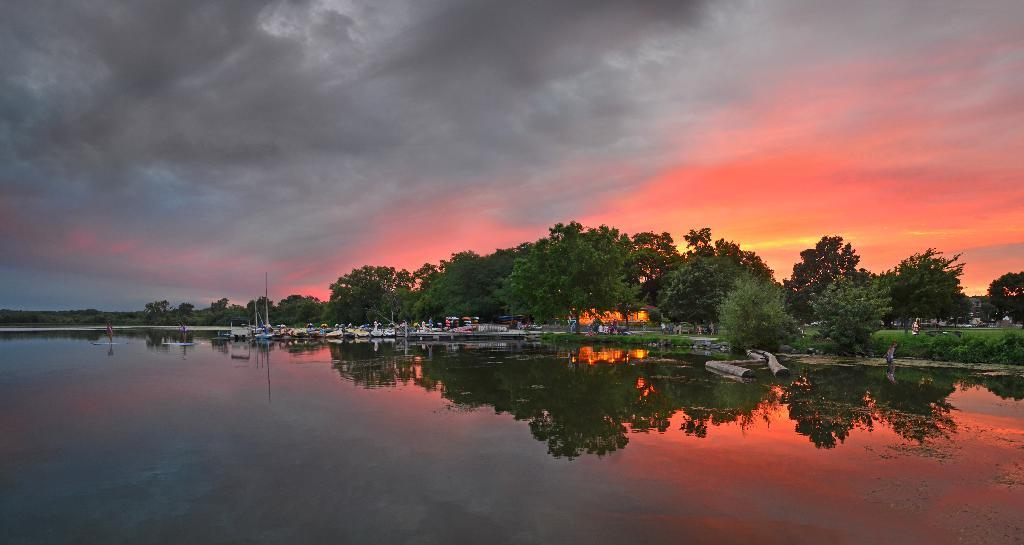What can be seen in the middle of the image? There are trees, boats, and plants in the middle of the image. What is located at the bottom of the image? There is water at the bottom of the image. What is visible at the top of the image? There is sky visible at the top of the image. What can be seen in the sky? There are clouds in the sky. Where is the stranger standing in the image? There is no stranger present in the image. What type of box can be seen in the image? There is no box present in the image. 